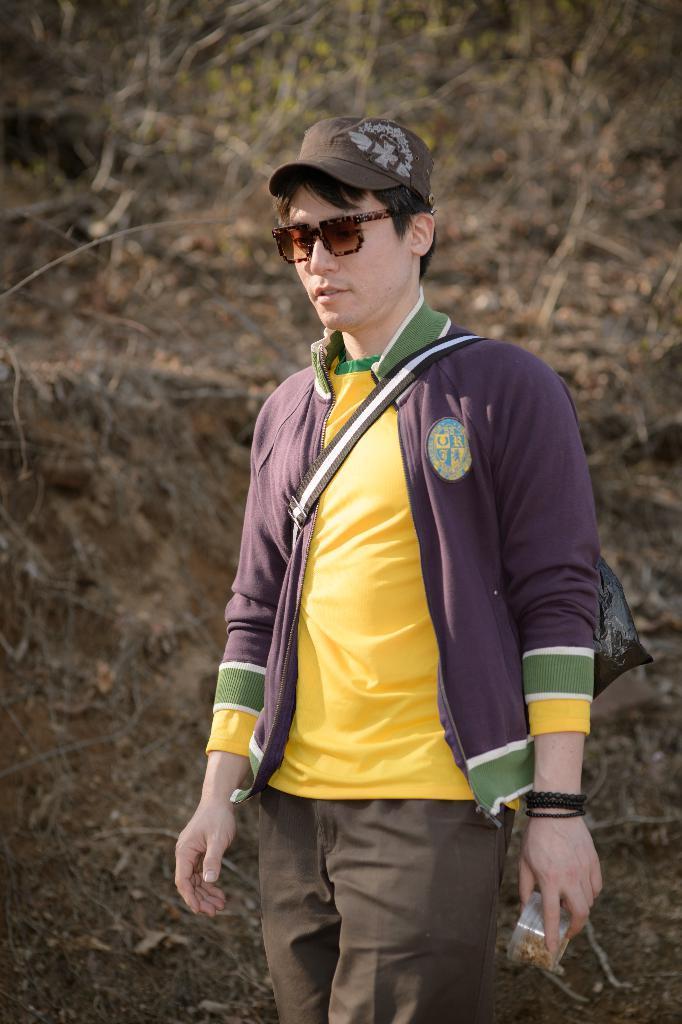Please provide a concise description of this image. This picture is clicked outside. In the foreground there is a person wearing yellow color t-shirt, sling bag, cap and holding an object and standing. In the background we can see the dry stems and the ground. 